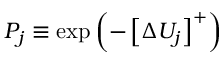<formula> <loc_0><loc_0><loc_500><loc_500>P _ { j } \equiv \exp \left ( - \left [ \Delta U _ { j } \right ] ^ { + } \right )</formula> 